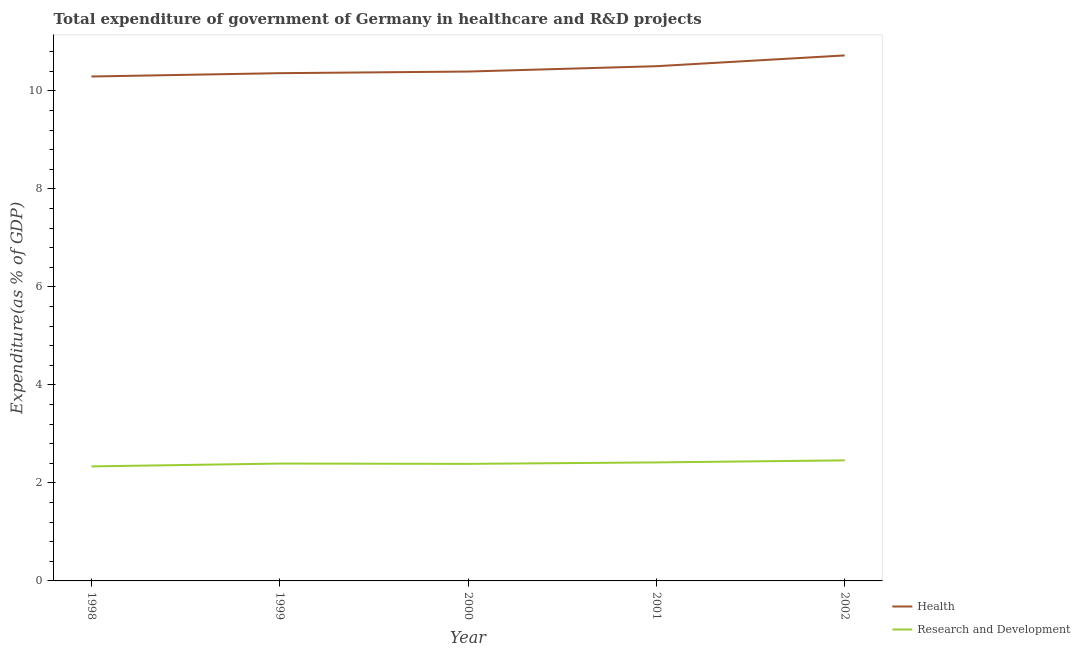How many different coloured lines are there?
Offer a terse response. 2. Is the number of lines equal to the number of legend labels?
Keep it short and to the point. Yes. What is the expenditure in r&d in 2001?
Give a very brief answer. 2.42. Across all years, what is the maximum expenditure in r&d?
Your answer should be very brief. 2.46. Across all years, what is the minimum expenditure in r&d?
Make the answer very short. 2.34. What is the total expenditure in r&d in the graph?
Your response must be concise. 12. What is the difference between the expenditure in r&d in 1998 and that in 2001?
Give a very brief answer. -0.08. What is the difference between the expenditure in healthcare in 2002 and the expenditure in r&d in 1999?
Your answer should be very brief. 8.33. What is the average expenditure in healthcare per year?
Your response must be concise. 10.46. In the year 2002, what is the difference between the expenditure in healthcare and expenditure in r&d?
Your response must be concise. 8.26. What is the ratio of the expenditure in healthcare in 1998 to that in 1999?
Offer a terse response. 0.99. Is the expenditure in healthcare in 1998 less than that in 2001?
Your response must be concise. Yes. What is the difference between the highest and the second highest expenditure in healthcare?
Give a very brief answer. 0.22. What is the difference between the highest and the lowest expenditure in healthcare?
Make the answer very short. 0.43. In how many years, is the expenditure in r&d greater than the average expenditure in r&d taken over all years?
Offer a very short reply. 2. Is the sum of the expenditure in r&d in 2000 and 2002 greater than the maximum expenditure in healthcare across all years?
Make the answer very short. No. Does the expenditure in r&d monotonically increase over the years?
Keep it short and to the point. No. Is the expenditure in r&d strictly greater than the expenditure in healthcare over the years?
Make the answer very short. No. How many years are there in the graph?
Keep it short and to the point. 5. Are the values on the major ticks of Y-axis written in scientific E-notation?
Your response must be concise. No. Does the graph contain any zero values?
Your response must be concise. No. Does the graph contain grids?
Keep it short and to the point. No. Where does the legend appear in the graph?
Provide a short and direct response. Bottom right. How many legend labels are there?
Your answer should be compact. 2. What is the title of the graph?
Offer a very short reply. Total expenditure of government of Germany in healthcare and R&D projects. What is the label or title of the X-axis?
Give a very brief answer. Year. What is the label or title of the Y-axis?
Your response must be concise. Expenditure(as % of GDP). What is the Expenditure(as % of GDP) in Health in 1998?
Your answer should be very brief. 10.29. What is the Expenditure(as % of GDP) of Research and Development in 1998?
Provide a succinct answer. 2.34. What is the Expenditure(as % of GDP) of Health in 1999?
Provide a short and direct response. 10.36. What is the Expenditure(as % of GDP) of Research and Development in 1999?
Offer a very short reply. 2.4. What is the Expenditure(as % of GDP) in Health in 2000?
Your answer should be very brief. 10.4. What is the Expenditure(as % of GDP) in Research and Development in 2000?
Your response must be concise. 2.39. What is the Expenditure(as % of GDP) of Health in 2001?
Your answer should be very brief. 10.5. What is the Expenditure(as % of GDP) of Research and Development in 2001?
Offer a very short reply. 2.42. What is the Expenditure(as % of GDP) of Health in 2002?
Provide a succinct answer. 10.72. What is the Expenditure(as % of GDP) of Research and Development in 2002?
Make the answer very short. 2.46. Across all years, what is the maximum Expenditure(as % of GDP) of Health?
Provide a succinct answer. 10.72. Across all years, what is the maximum Expenditure(as % of GDP) in Research and Development?
Provide a succinct answer. 2.46. Across all years, what is the minimum Expenditure(as % of GDP) in Health?
Offer a very short reply. 10.29. Across all years, what is the minimum Expenditure(as % of GDP) in Research and Development?
Give a very brief answer. 2.34. What is the total Expenditure(as % of GDP) of Health in the graph?
Give a very brief answer. 52.28. What is the total Expenditure(as % of GDP) in Research and Development in the graph?
Keep it short and to the point. 12. What is the difference between the Expenditure(as % of GDP) of Health in 1998 and that in 1999?
Offer a very short reply. -0.07. What is the difference between the Expenditure(as % of GDP) of Research and Development in 1998 and that in 1999?
Your response must be concise. -0.06. What is the difference between the Expenditure(as % of GDP) of Health in 1998 and that in 2000?
Your answer should be very brief. -0.1. What is the difference between the Expenditure(as % of GDP) of Research and Development in 1998 and that in 2000?
Offer a very short reply. -0.05. What is the difference between the Expenditure(as % of GDP) in Health in 1998 and that in 2001?
Provide a short and direct response. -0.21. What is the difference between the Expenditure(as % of GDP) in Research and Development in 1998 and that in 2001?
Your response must be concise. -0.08. What is the difference between the Expenditure(as % of GDP) of Health in 1998 and that in 2002?
Provide a short and direct response. -0.43. What is the difference between the Expenditure(as % of GDP) of Research and Development in 1998 and that in 2002?
Your answer should be very brief. -0.12. What is the difference between the Expenditure(as % of GDP) in Health in 1999 and that in 2000?
Ensure brevity in your answer.  -0.03. What is the difference between the Expenditure(as % of GDP) of Research and Development in 1999 and that in 2000?
Give a very brief answer. 0.01. What is the difference between the Expenditure(as % of GDP) of Health in 1999 and that in 2001?
Offer a very short reply. -0.14. What is the difference between the Expenditure(as % of GDP) in Research and Development in 1999 and that in 2001?
Your response must be concise. -0.02. What is the difference between the Expenditure(as % of GDP) of Health in 1999 and that in 2002?
Your response must be concise. -0.36. What is the difference between the Expenditure(as % of GDP) in Research and Development in 1999 and that in 2002?
Your response must be concise. -0.06. What is the difference between the Expenditure(as % of GDP) in Health in 2000 and that in 2001?
Keep it short and to the point. -0.11. What is the difference between the Expenditure(as % of GDP) in Research and Development in 2000 and that in 2001?
Keep it short and to the point. -0.03. What is the difference between the Expenditure(as % of GDP) of Health in 2000 and that in 2002?
Provide a short and direct response. -0.33. What is the difference between the Expenditure(as % of GDP) in Research and Development in 2000 and that in 2002?
Provide a succinct answer. -0.07. What is the difference between the Expenditure(as % of GDP) in Health in 2001 and that in 2002?
Provide a short and direct response. -0.22. What is the difference between the Expenditure(as % of GDP) of Research and Development in 2001 and that in 2002?
Ensure brevity in your answer.  -0.04. What is the difference between the Expenditure(as % of GDP) of Health in 1998 and the Expenditure(as % of GDP) of Research and Development in 1999?
Keep it short and to the point. 7.9. What is the difference between the Expenditure(as % of GDP) of Health in 1998 and the Expenditure(as % of GDP) of Research and Development in 2000?
Keep it short and to the point. 7.91. What is the difference between the Expenditure(as % of GDP) of Health in 1998 and the Expenditure(as % of GDP) of Research and Development in 2001?
Provide a succinct answer. 7.88. What is the difference between the Expenditure(as % of GDP) of Health in 1998 and the Expenditure(as % of GDP) of Research and Development in 2002?
Offer a very short reply. 7.83. What is the difference between the Expenditure(as % of GDP) of Health in 1999 and the Expenditure(as % of GDP) of Research and Development in 2000?
Provide a short and direct response. 7.97. What is the difference between the Expenditure(as % of GDP) in Health in 1999 and the Expenditure(as % of GDP) in Research and Development in 2001?
Your answer should be very brief. 7.94. What is the difference between the Expenditure(as % of GDP) in Health in 1999 and the Expenditure(as % of GDP) in Research and Development in 2002?
Your response must be concise. 7.9. What is the difference between the Expenditure(as % of GDP) in Health in 2000 and the Expenditure(as % of GDP) in Research and Development in 2001?
Keep it short and to the point. 7.98. What is the difference between the Expenditure(as % of GDP) of Health in 2000 and the Expenditure(as % of GDP) of Research and Development in 2002?
Provide a short and direct response. 7.94. What is the difference between the Expenditure(as % of GDP) of Health in 2001 and the Expenditure(as % of GDP) of Research and Development in 2002?
Offer a terse response. 8.04. What is the average Expenditure(as % of GDP) in Health per year?
Offer a very short reply. 10.46. In the year 1998, what is the difference between the Expenditure(as % of GDP) in Health and Expenditure(as % of GDP) in Research and Development?
Provide a short and direct response. 7.96. In the year 1999, what is the difference between the Expenditure(as % of GDP) of Health and Expenditure(as % of GDP) of Research and Development?
Keep it short and to the point. 7.97. In the year 2000, what is the difference between the Expenditure(as % of GDP) in Health and Expenditure(as % of GDP) in Research and Development?
Your answer should be very brief. 8.01. In the year 2001, what is the difference between the Expenditure(as % of GDP) in Health and Expenditure(as % of GDP) in Research and Development?
Your answer should be very brief. 8.09. In the year 2002, what is the difference between the Expenditure(as % of GDP) in Health and Expenditure(as % of GDP) in Research and Development?
Offer a terse response. 8.26. What is the ratio of the Expenditure(as % of GDP) of Health in 1998 to that in 1999?
Provide a short and direct response. 0.99. What is the ratio of the Expenditure(as % of GDP) in Research and Development in 1998 to that in 1999?
Make the answer very short. 0.98. What is the ratio of the Expenditure(as % of GDP) in Health in 1998 to that in 2000?
Your response must be concise. 0.99. What is the ratio of the Expenditure(as % of GDP) in Research and Development in 1998 to that in 2000?
Give a very brief answer. 0.98. What is the ratio of the Expenditure(as % of GDP) of Research and Development in 1998 to that in 2001?
Provide a succinct answer. 0.97. What is the ratio of the Expenditure(as % of GDP) in Health in 1998 to that in 2002?
Your answer should be compact. 0.96. What is the ratio of the Expenditure(as % of GDP) of Research and Development in 1998 to that in 2002?
Your answer should be very brief. 0.95. What is the ratio of the Expenditure(as % of GDP) in Health in 1999 to that in 2000?
Ensure brevity in your answer.  1. What is the ratio of the Expenditure(as % of GDP) in Research and Development in 1999 to that in 2000?
Your answer should be very brief. 1. What is the ratio of the Expenditure(as % of GDP) in Health in 1999 to that in 2001?
Give a very brief answer. 0.99. What is the ratio of the Expenditure(as % of GDP) of Research and Development in 1999 to that in 2001?
Offer a very short reply. 0.99. What is the ratio of the Expenditure(as % of GDP) of Health in 1999 to that in 2002?
Provide a succinct answer. 0.97. What is the ratio of the Expenditure(as % of GDP) of Research and Development in 1999 to that in 2002?
Your answer should be very brief. 0.97. What is the ratio of the Expenditure(as % of GDP) of Health in 2000 to that in 2001?
Offer a terse response. 0.99. What is the ratio of the Expenditure(as % of GDP) in Research and Development in 2000 to that in 2001?
Ensure brevity in your answer.  0.99. What is the ratio of the Expenditure(as % of GDP) of Health in 2000 to that in 2002?
Your answer should be compact. 0.97. What is the ratio of the Expenditure(as % of GDP) in Research and Development in 2000 to that in 2002?
Ensure brevity in your answer.  0.97. What is the ratio of the Expenditure(as % of GDP) of Health in 2001 to that in 2002?
Make the answer very short. 0.98. What is the ratio of the Expenditure(as % of GDP) in Research and Development in 2001 to that in 2002?
Make the answer very short. 0.98. What is the difference between the highest and the second highest Expenditure(as % of GDP) in Health?
Give a very brief answer. 0.22. What is the difference between the highest and the second highest Expenditure(as % of GDP) in Research and Development?
Offer a very short reply. 0.04. What is the difference between the highest and the lowest Expenditure(as % of GDP) of Health?
Keep it short and to the point. 0.43. What is the difference between the highest and the lowest Expenditure(as % of GDP) of Research and Development?
Your response must be concise. 0.12. 